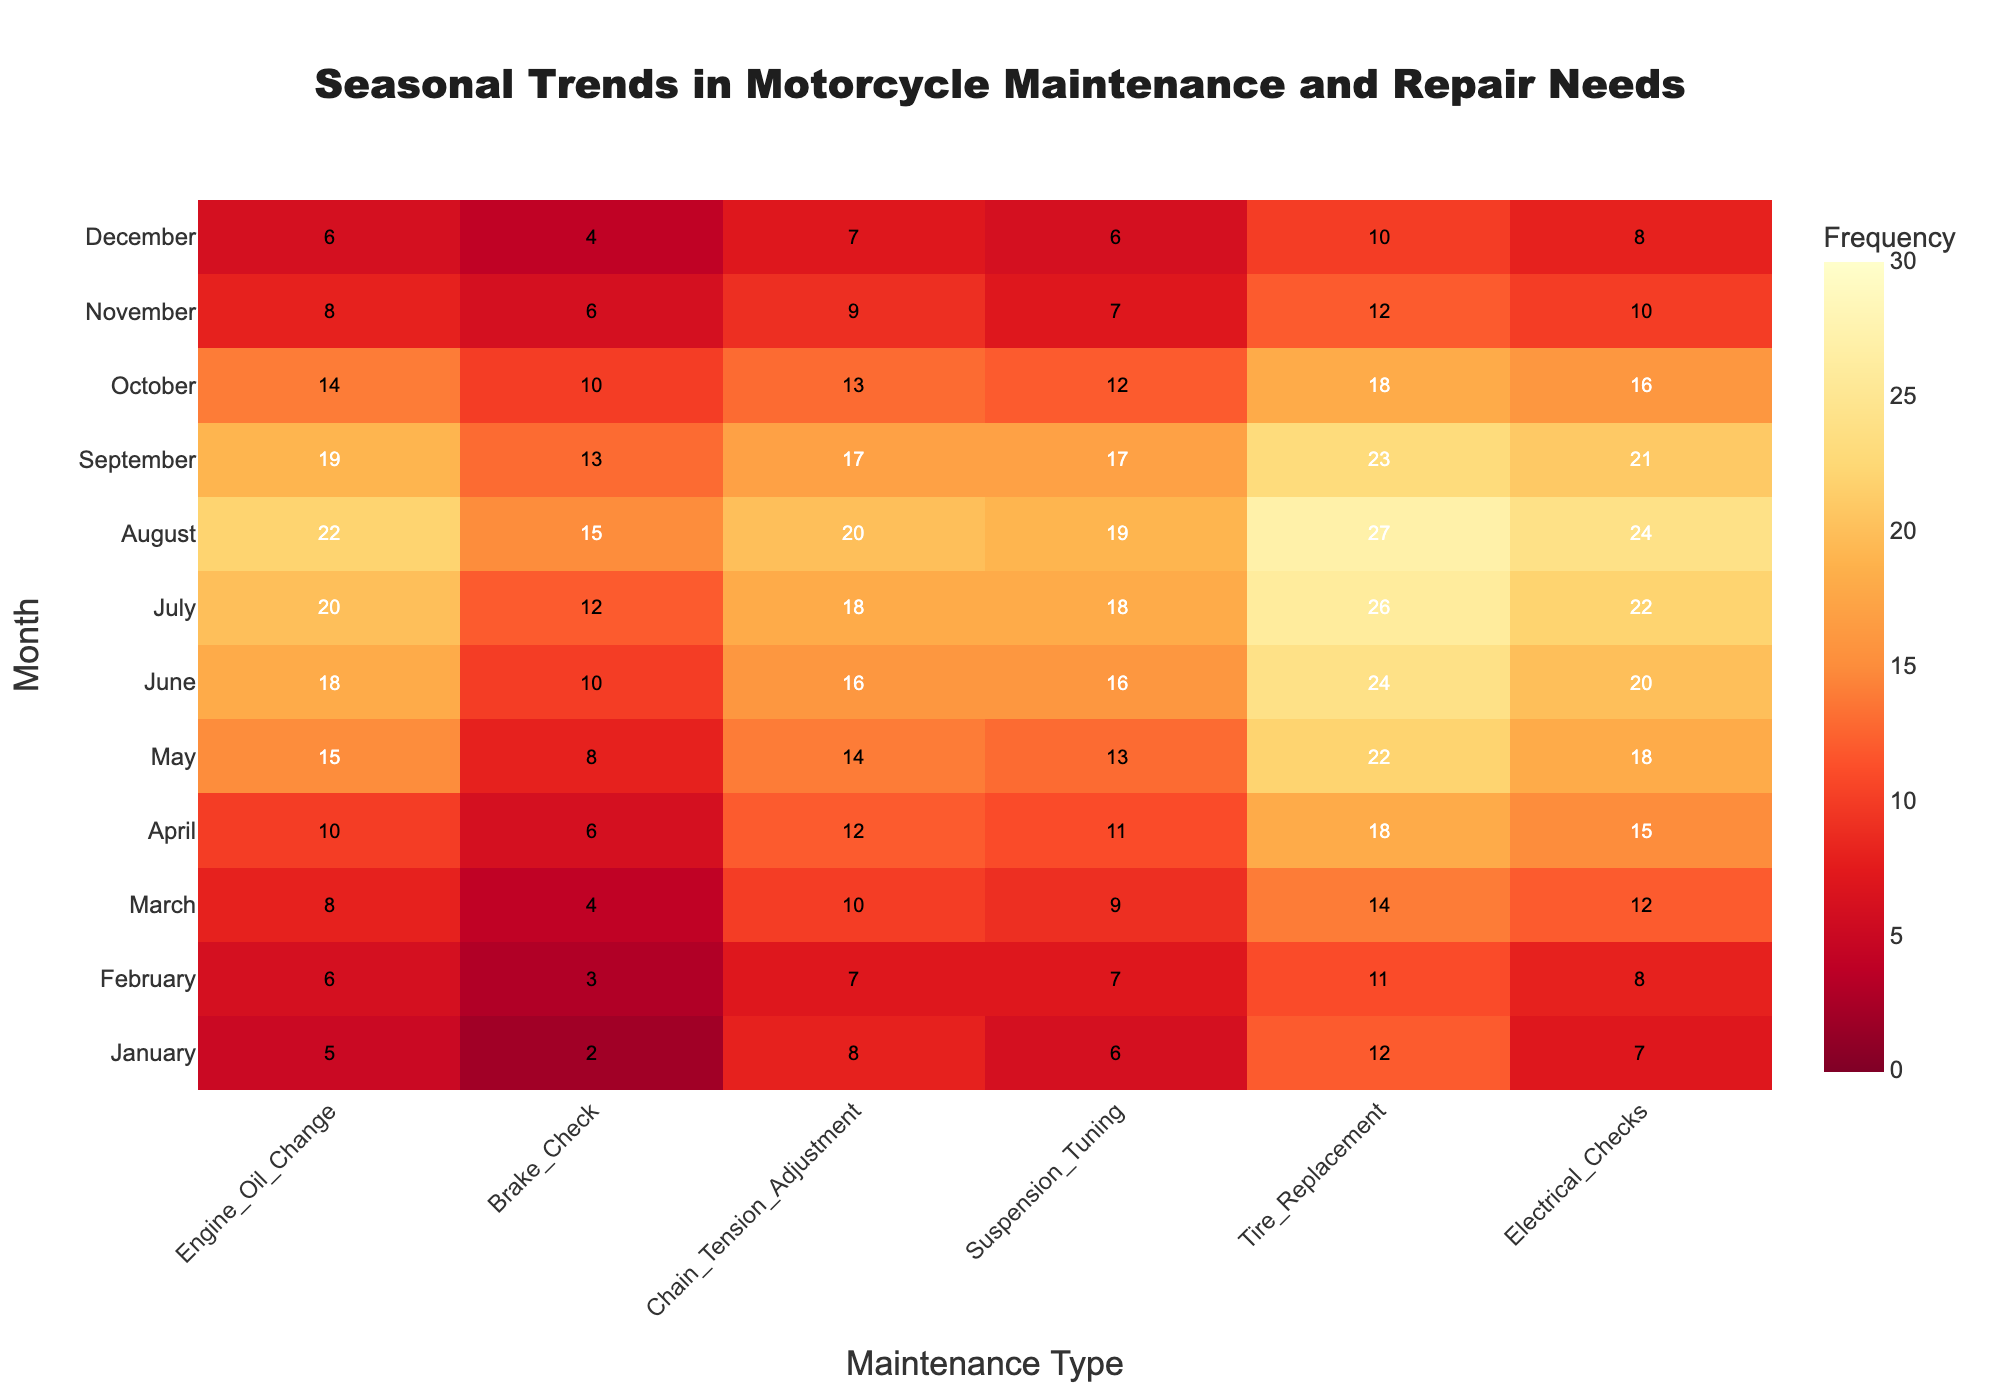What is the title of the heatmap? The title is prominently displayed at the top of the heatmap. It reads "Seasonal Trends in Motorcycle Maintenance and Repair Needs".
Answer: Seasonal Trends in Motorcycle Maintenance and Repair Needs Which maintenance type has the highest frequency in July? By checking the color intensity and annotations in the July row, the maintenance type with the highest value is Tire Replacement, which is annotated with 26.
Answer: Tire Replacement During which month is Electrical Checks least frequent? In the Electrical Checks column, the lightest color (representing the smallest number) is seen in January and December, each with a value of 7 and 8, respectively. January has the lowest.
Answer: January What is the average frequency of Brake Checks across all months? To find the average, sum all the values in the Brake Checks column (2 + 3 + 4 + 6 + 8 + 10 + 12 + 15 + 13 + 10 + 6 + 4) which equals 93, and then divide by the number of months (12). The calculation is 93 / 12 = 7.75.
Answer: 7.75 Which month has the highest total frequency across all maintenance types? Add up the frequencies for all maintenance types for each month and find the month with the highest total. August has the highest sum: 22 (Engine Oil Change) + 15 (Brake Checks) + 20 (Chain Tension Adjustment) + 19 (Suspension Tuning) + 27 (Tire Replacement) + 24 (Electrical Checks) = 127.
Answer: August Compare the frequency of Engine Oil Changes in March and September. Which month has more, and by how much? The value for March is 8 and for September is 19. To find the difference, subtract 8 from 19, resulting in a difference of 11. September has 11 more Engine Oil Changes than March.
Answer: September, 11 Which maintenance type shows the smallest variation in frequency over the year? By looking at the range of each maintenance type column, the Electrical Checks column shows the least variation, with values from 7 to 24, a range of 17. The other columns display more drastic ranges.
Answer: Electrical Checks What's the sum of Tire Replacement frequencies for April and October? Add the Tire Replacement values for April and October: 18 (April) + 18 (October) = 36.
Answer: 36 During which months are Chain Tension Adjustments most and least frequent, and what are those frequencies? For most frequent, check the highest value in the Chain Tension Adjustments column, which is in August with 20. The least frequent is in January with 8.
Answer: August, 20 and January, 8 